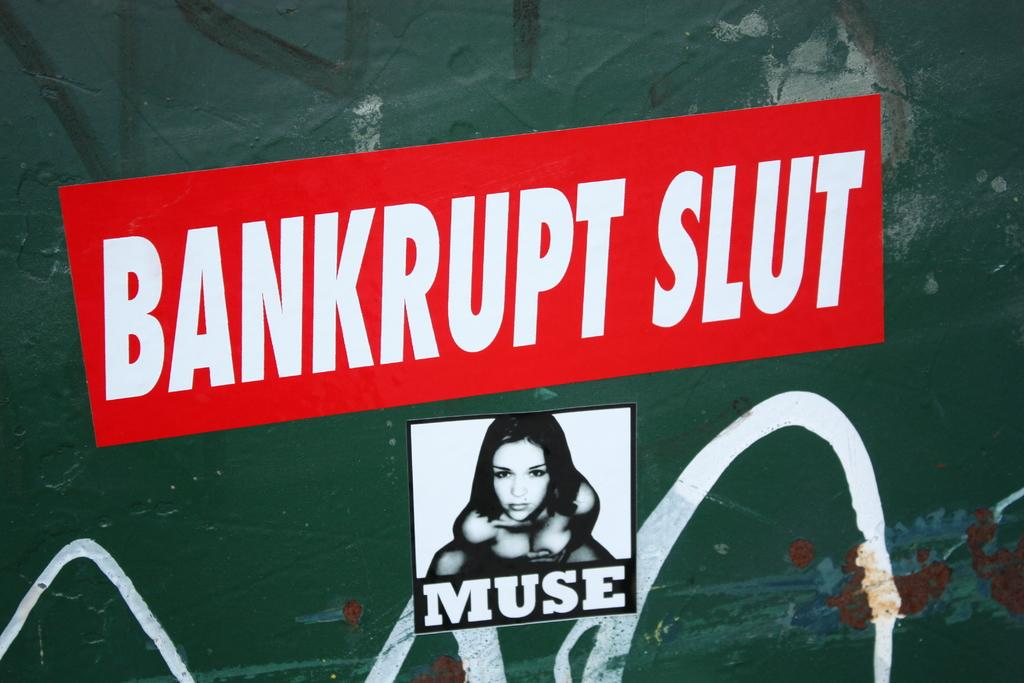Provide a one-sentence caption for the provided image. Red sticker with white text that says "Bankrupt Slut". 